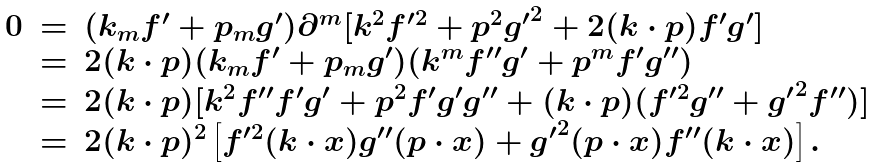<formula> <loc_0><loc_0><loc_500><loc_500>\begin{array} { c c l } 0 & = & ( k _ { m } f ^ { \prime } + p _ { m } g ^ { \prime } ) \partial ^ { m } [ k ^ { 2 } f ^ { \prime 2 } + p ^ { 2 } { g ^ { \prime } } ^ { 2 } + 2 ( k \cdot p ) f ^ { \prime } g ^ { \prime } ] \\ & = & 2 ( k \cdot p ) ( k _ { m } f ^ { \prime } + p _ { m } g ^ { \prime } ) ( k ^ { m } f ^ { \prime \prime } g ^ { \prime } + p ^ { m } f ^ { \prime } g ^ { \prime \prime } ) \\ & = & 2 ( k \cdot p ) [ k ^ { 2 } f ^ { \prime \prime } f ^ { \prime } g ^ { \prime } + p ^ { 2 } f ^ { \prime } g ^ { \prime } g ^ { \prime \prime } + ( k \cdot p ) ( f ^ { \prime 2 } g ^ { \prime \prime } + { g ^ { \prime } } ^ { 2 } f ^ { \prime \prime } ) ] \\ & = & 2 ( k \cdot p ) ^ { 2 } \left [ f ^ { \prime 2 } ( k \cdot x ) g ^ { \prime \prime } ( p \cdot x ) + { g ^ { \prime } } ^ { 2 } ( p \cdot x ) f ^ { \prime \prime } ( k \cdot x ) \right ] . \end{array}</formula> 